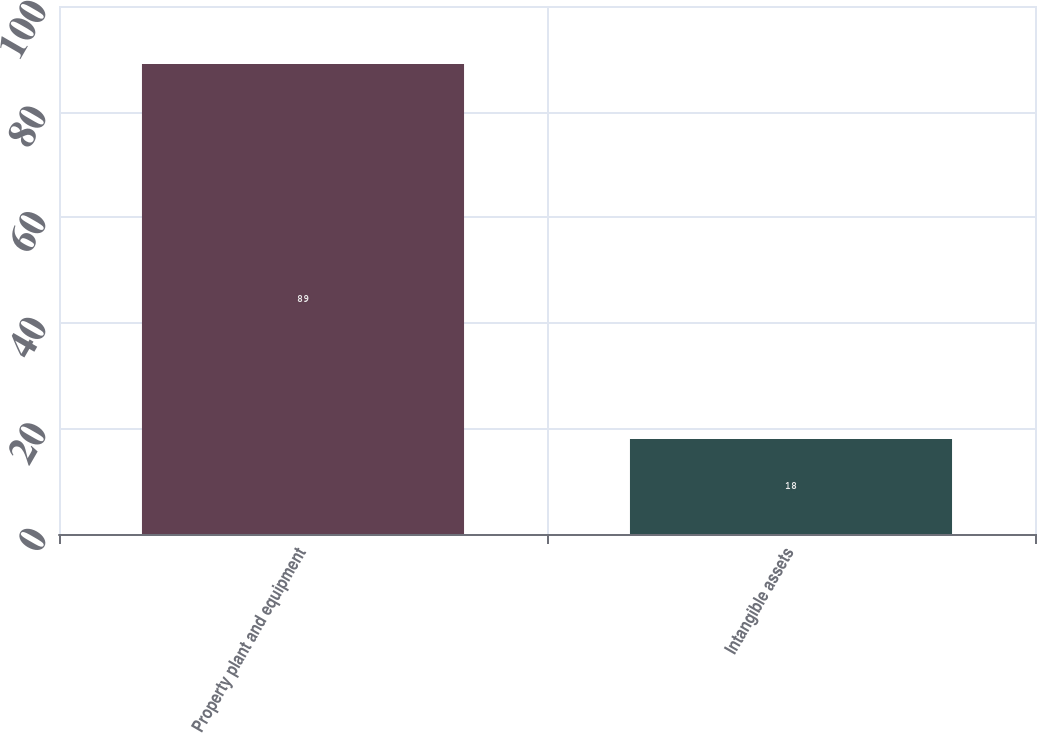<chart> <loc_0><loc_0><loc_500><loc_500><bar_chart><fcel>Property plant and equipment<fcel>Intangible assets<nl><fcel>89<fcel>18<nl></chart> 